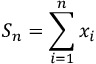<formula> <loc_0><loc_0><loc_500><loc_500>S _ { n } = \sum _ { i = 1 } ^ { n } x _ { i }</formula> 